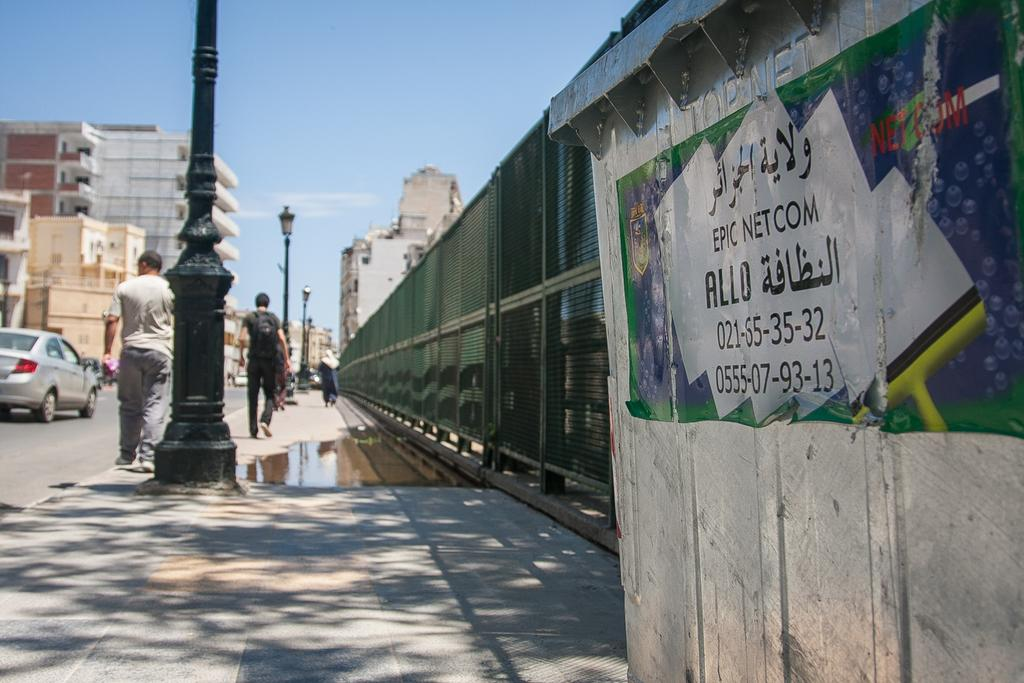What are the people in the image doing? The persons in the image are walking on a footpath. What else can be seen on the same surface as the people? Vehicles are present on the road. What can be seen in the distance behind the people and vehicles? There are buildings visible in the background. What is visible above the buildings and vehicles? The sky is visible in the background. What type of chain can be seen hanging from the table in the image? There is no table or chain present in the image. 